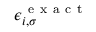<formula> <loc_0><loc_0><loc_500><loc_500>\epsilon _ { i , \sigma } ^ { e x a c t }</formula> 